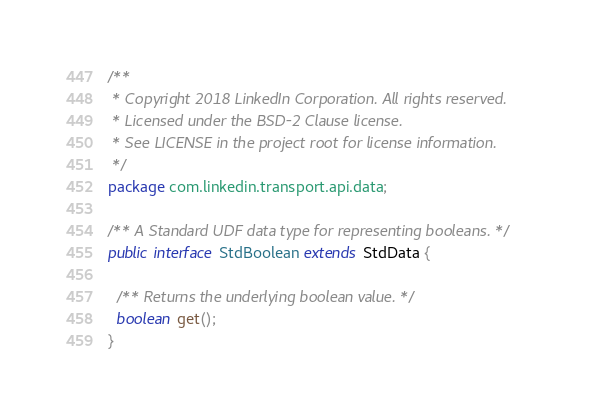Convert code to text. <code><loc_0><loc_0><loc_500><loc_500><_Java_>/**
 * Copyright 2018 LinkedIn Corporation. All rights reserved.
 * Licensed under the BSD-2 Clause license.
 * See LICENSE in the project root for license information.
 */
package com.linkedin.transport.api.data;

/** A Standard UDF data type for representing booleans. */
public interface StdBoolean extends StdData {

  /** Returns the underlying boolean value. */
  boolean get();
}
</code> 